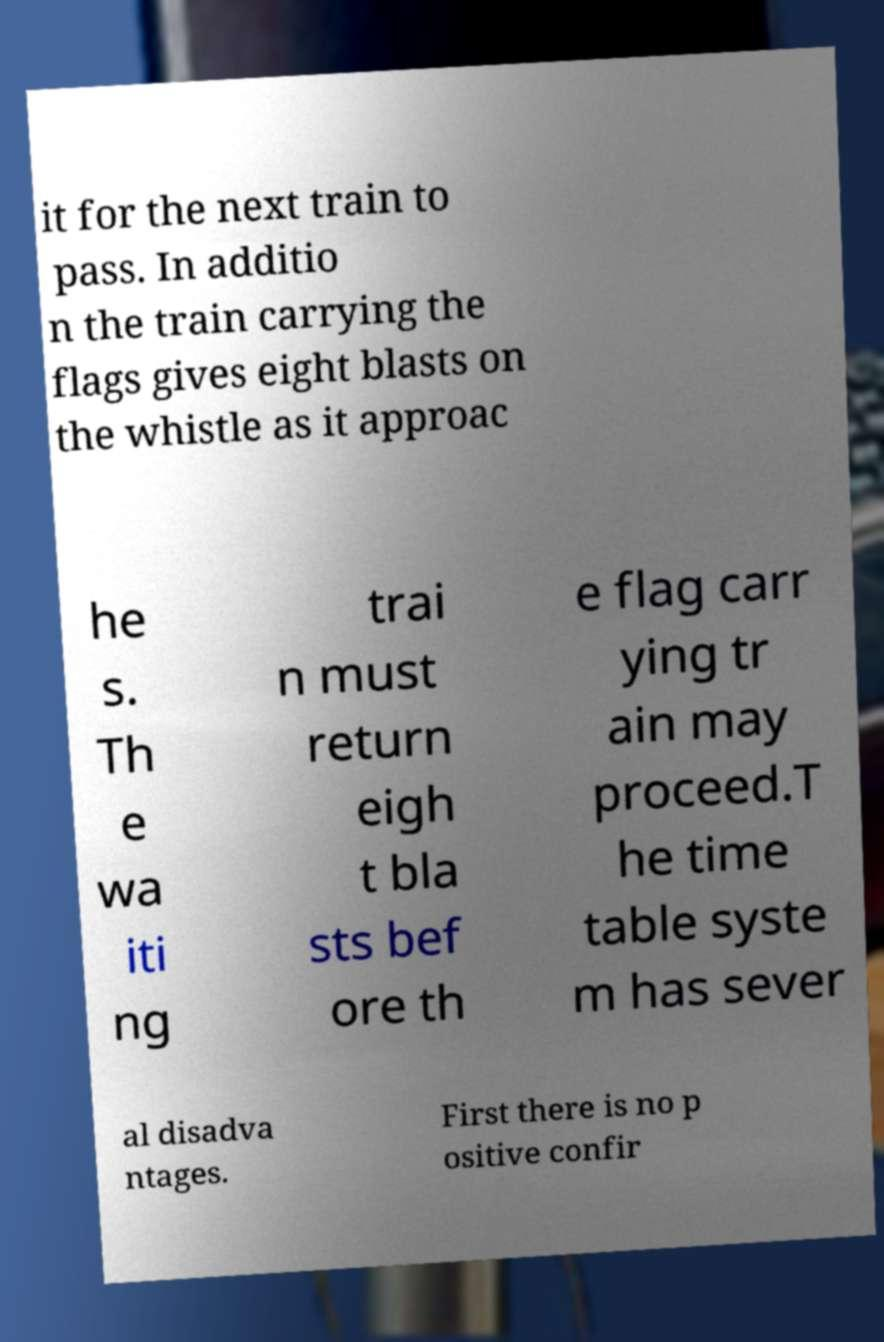I need the written content from this picture converted into text. Can you do that? it for the next train to pass. In additio n the train carrying the flags gives eight blasts on the whistle as it approac he s. Th e wa iti ng trai n must return eigh t bla sts bef ore th e flag carr ying tr ain may proceed.T he time table syste m has sever al disadva ntages. First there is no p ositive confir 